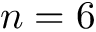Convert formula to latex. <formula><loc_0><loc_0><loc_500><loc_500>n = 6</formula> 